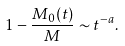Convert formula to latex. <formula><loc_0><loc_0><loc_500><loc_500>1 - \frac { M _ { 0 } ( t ) } { M } \sim t ^ { - a } .</formula> 